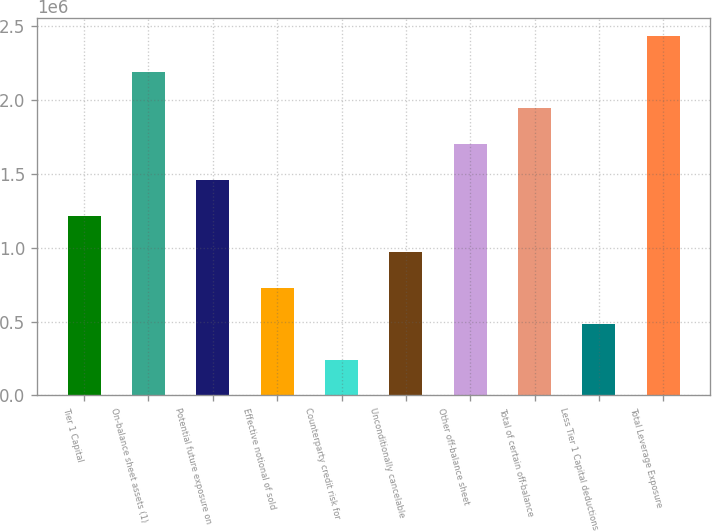Convert chart. <chart><loc_0><loc_0><loc_500><loc_500><bar_chart><fcel>Tier 1 Capital<fcel>On-balance sheet assets (1)<fcel>Potential future exposure on<fcel>Effective notional of sold<fcel>Counterparty credit risk for<fcel>Unconditionally cancelable<fcel>Other off-balance sheet<fcel>Total of certain off-balance<fcel>Less Tier 1 Capital deductions<fcel>Total Leverage Exposure<nl><fcel>1.21625e+06<fcel>2.18924e+06<fcel>1.4595e+06<fcel>729752<fcel>243255<fcel>973000<fcel>1.70275e+06<fcel>1.94599e+06<fcel>486504<fcel>2.43249e+06<nl></chart> 